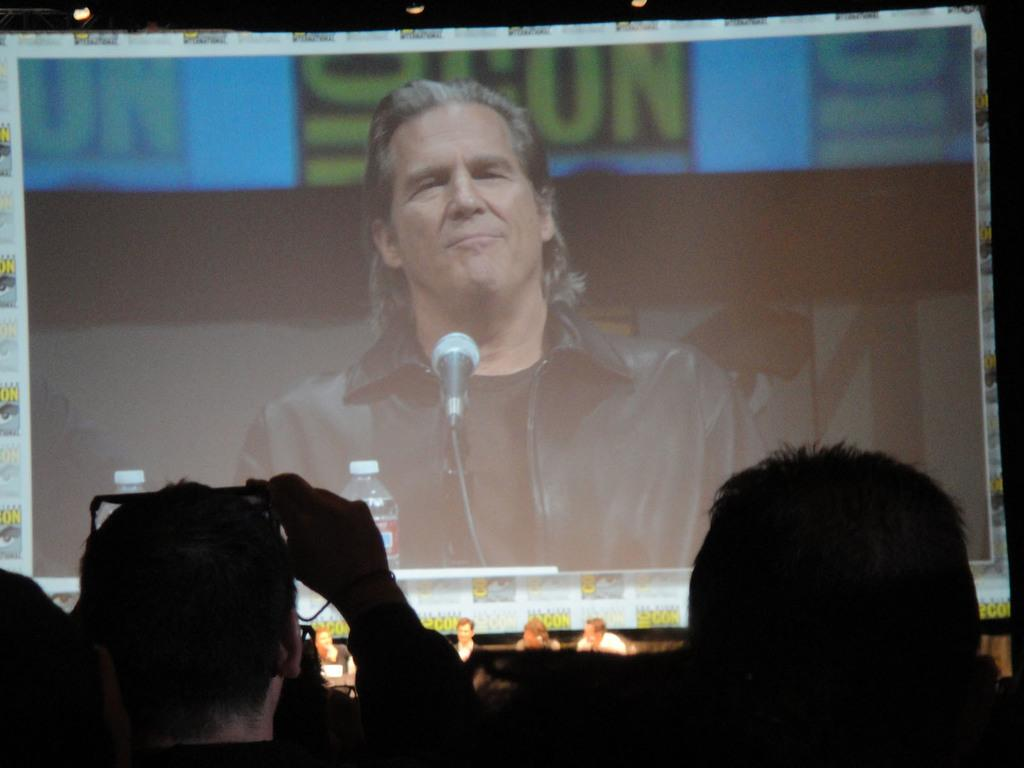What can be seen in the image related to people? There are people's heads visible in the image, and there are people in the background. What is present in the background of the image? There is a screen in the background of the image. What is happening on the screen? A man is visible on the screen. What items are in front of the man on the screen? There are bottles and a microphone in front of the man on the screen. What type of bone is visible in the image? There is no bone visible in the image. Can you see an airplane in the image? No, there is no airplane present in the image. 